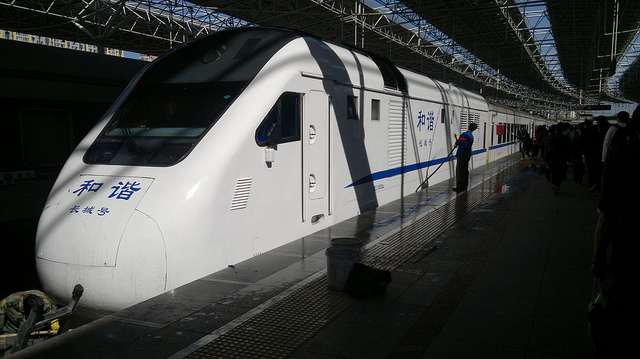<image>What type of aircraft is pictured? There is no aircraft in the image. It could be a train or shuttle. What type of aircraft is pictured? It is unknown what type of aircraft is pictured. There is no aircraft in the image. 